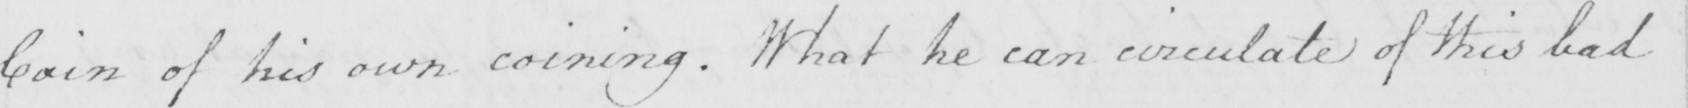What does this handwritten line say? Coin of his own coining . What he can circulate of this bad 